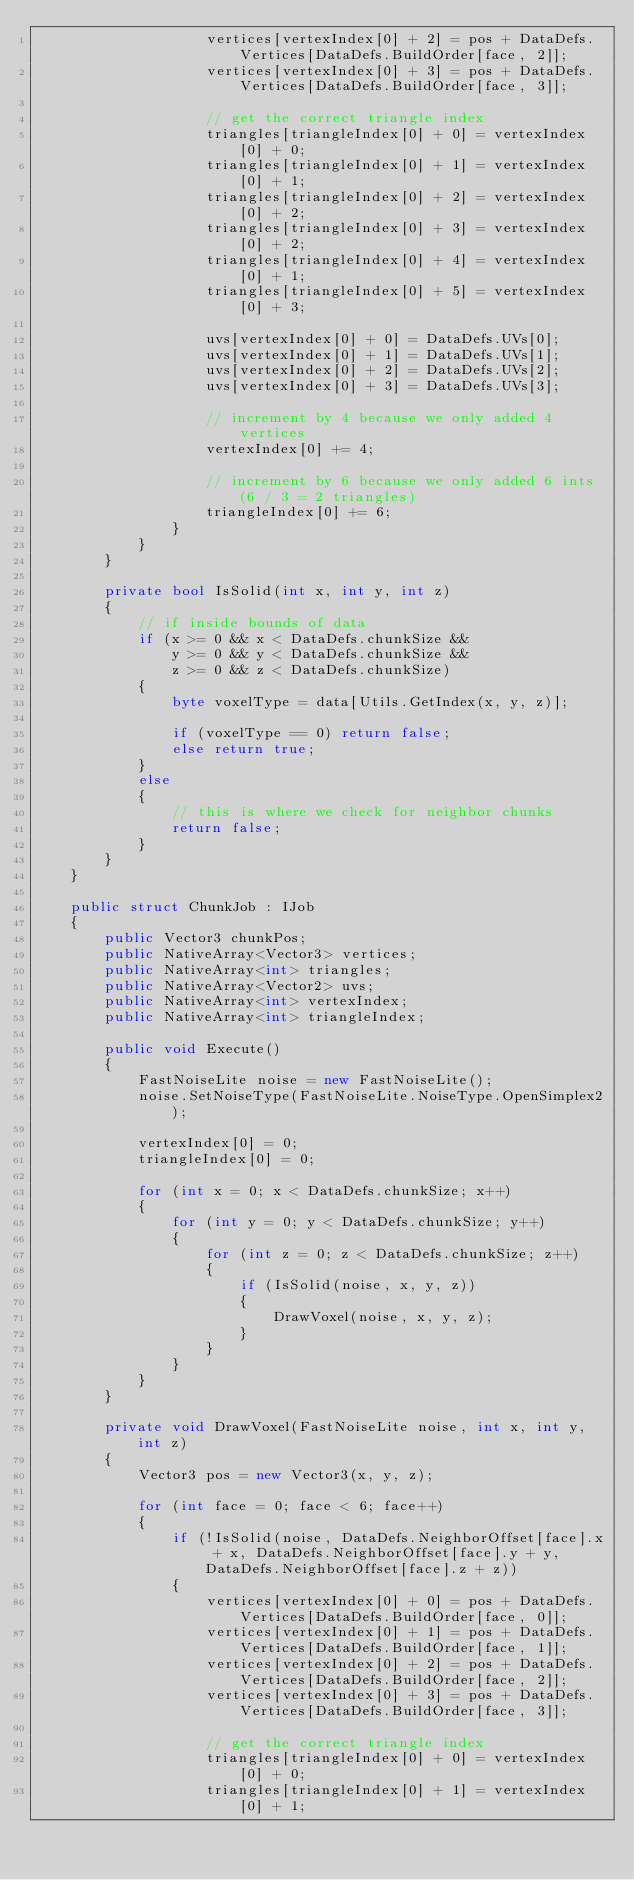Convert code to text. <code><loc_0><loc_0><loc_500><loc_500><_C#_>                    vertices[vertexIndex[0] + 2] = pos + DataDefs.Vertices[DataDefs.BuildOrder[face, 2]];
                    vertices[vertexIndex[0] + 3] = pos + DataDefs.Vertices[DataDefs.BuildOrder[face, 3]];

                    // get the correct triangle index
                    triangles[triangleIndex[0] + 0] = vertexIndex[0] + 0;
                    triangles[triangleIndex[0] + 1] = vertexIndex[0] + 1;
                    triangles[triangleIndex[0] + 2] = vertexIndex[0] + 2;
                    triangles[triangleIndex[0] + 3] = vertexIndex[0] + 2;
                    triangles[triangleIndex[0] + 4] = vertexIndex[0] + 1;
                    triangles[triangleIndex[0] + 5] = vertexIndex[0] + 3;

                    uvs[vertexIndex[0] + 0] = DataDefs.UVs[0];
                    uvs[vertexIndex[0] + 1] = DataDefs.UVs[1];
                    uvs[vertexIndex[0] + 2] = DataDefs.UVs[2];
                    uvs[vertexIndex[0] + 3] = DataDefs.UVs[3];

                    // increment by 4 because we only added 4 vertices
                    vertexIndex[0] += 4;

                    // increment by 6 because we only added 6 ints (6 / 3 = 2 triangles)
                    triangleIndex[0] += 6;
                }
            }
        }

        private bool IsSolid(int x, int y, int z)
        {
            // if inside bounds of data
            if (x >= 0 && x < DataDefs.chunkSize &&
                y >= 0 && y < DataDefs.chunkSize &&
                z >= 0 && z < DataDefs.chunkSize)
            {
                byte voxelType = data[Utils.GetIndex(x, y, z)];

                if (voxelType == 0) return false;
                else return true;
            }
            else
            {
                // this is where we check for neighbor chunks
                return false;
            }
        }
    }

    public struct ChunkJob : IJob
    {
        public Vector3 chunkPos;
        public NativeArray<Vector3> vertices;
        public NativeArray<int> triangles;
        public NativeArray<Vector2> uvs;
        public NativeArray<int> vertexIndex;
        public NativeArray<int> triangleIndex;

        public void Execute()
        {
            FastNoiseLite noise = new FastNoiseLite();
            noise.SetNoiseType(FastNoiseLite.NoiseType.OpenSimplex2);

            vertexIndex[0] = 0;
            triangleIndex[0] = 0;

            for (int x = 0; x < DataDefs.chunkSize; x++)
            {
                for (int y = 0; y < DataDefs.chunkSize; y++)
                {
                    for (int z = 0; z < DataDefs.chunkSize; z++)
                    {
                        if (IsSolid(noise, x, y, z))
                        {
                            DrawVoxel(noise, x, y, z);
                        }
                    }
                }
            }
        }

        private void DrawVoxel(FastNoiseLite noise, int x, int y, int z)
        {
            Vector3 pos = new Vector3(x, y, z);

            for (int face = 0; face < 6; face++)
            {
                if (!IsSolid(noise, DataDefs.NeighborOffset[face].x + x, DataDefs.NeighborOffset[face].y + y, DataDefs.NeighborOffset[face].z + z))
                {
                    vertices[vertexIndex[0] + 0] = pos + DataDefs.Vertices[DataDefs.BuildOrder[face, 0]];
                    vertices[vertexIndex[0] + 1] = pos + DataDefs.Vertices[DataDefs.BuildOrder[face, 1]];
                    vertices[vertexIndex[0] + 2] = pos + DataDefs.Vertices[DataDefs.BuildOrder[face, 2]];
                    vertices[vertexIndex[0] + 3] = pos + DataDefs.Vertices[DataDefs.BuildOrder[face, 3]];

                    // get the correct triangle index
                    triangles[triangleIndex[0] + 0] = vertexIndex[0] + 0;
                    triangles[triangleIndex[0] + 1] = vertexIndex[0] + 1;</code> 